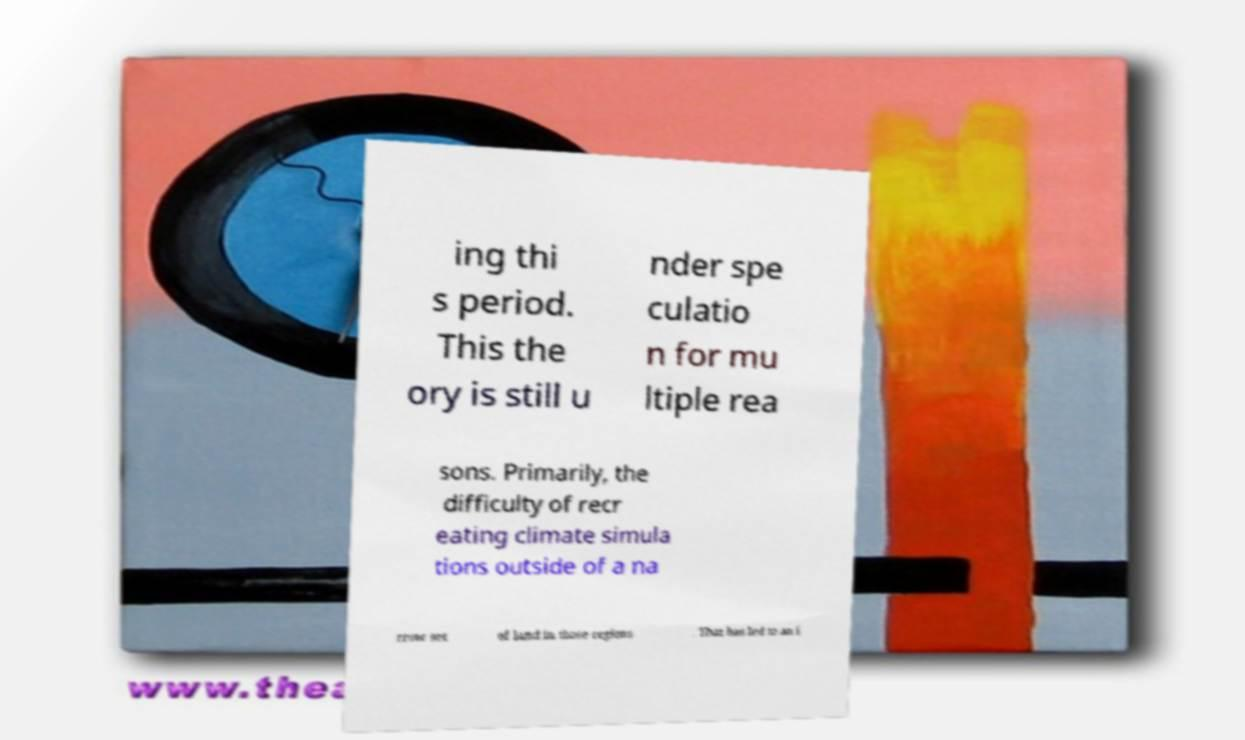There's text embedded in this image that I need extracted. Can you transcribe it verbatim? ing thi s period. This the ory is still u nder spe culatio n for mu ltiple rea sons. Primarily, the difficulty of recr eating climate simula tions outside of a na rrow set of land in those regions . That has led to an i 